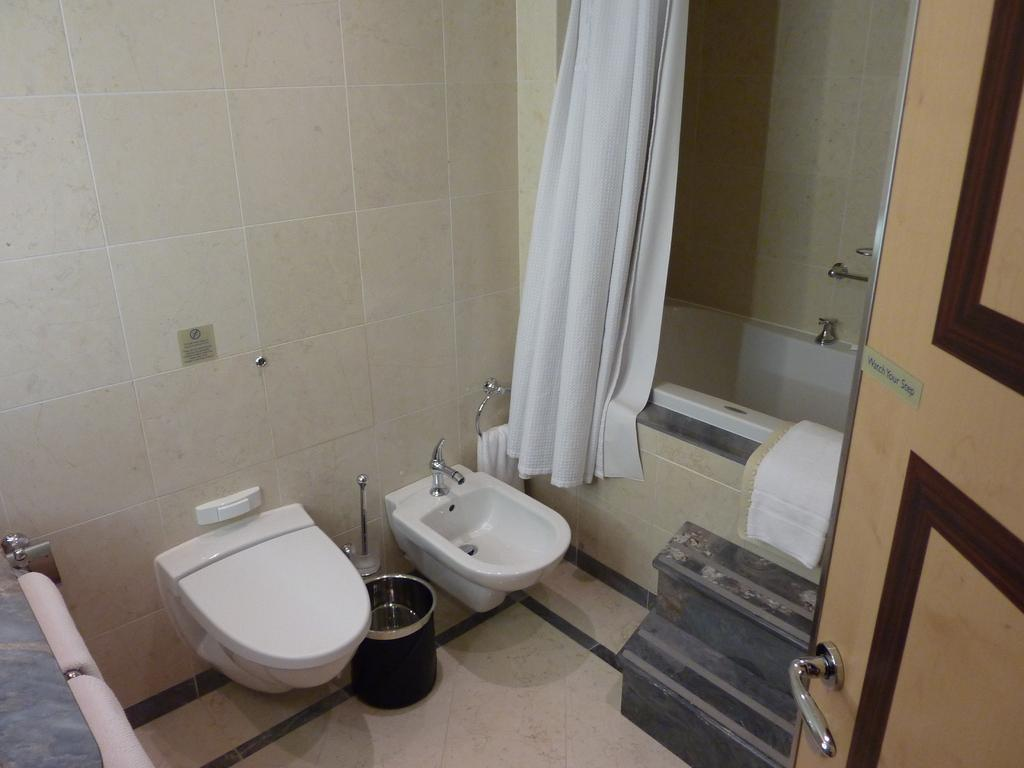What type of fixture is present in the image? There is a toilet seat in the image. What other bathroom fixture can be seen in the image? There is a sink in the image. Is there a bathtub in the image? Yes, there is a bathtub in the image. What is the background of the image made of? There is a wall in the image. Where is the door located in the image? The door is on the right side of the image. What is visible at the bottom of the image? There is a floor visible at the bottom of the image. How much money is being exchanged at the airport in the image? There is no airport or money exchange depicted in the image; it shows a bathroom with a toilet seat, sink, bathtub, wall, door, and floor. 